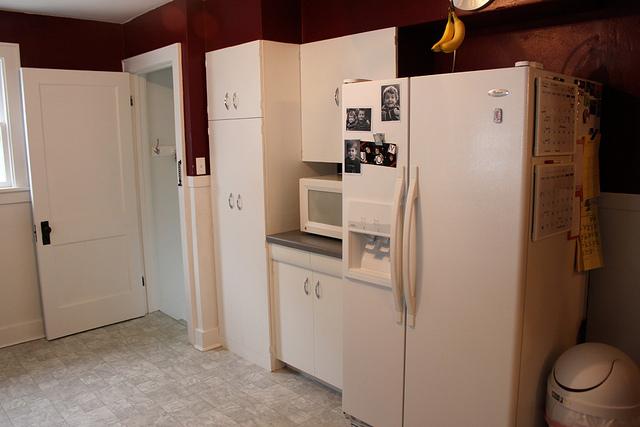Does this kitchen appear dirty?
Write a very short answer. No. How many appliances are there?
Be succinct. 2. Where is the photo taken?
Quick response, please. Kitchen. What kind of floor is this?
Concise answer only. Tile. How many bananas do they have?
Write a very short answer. 2. Is the entire area bare?
Short answer required. No. 